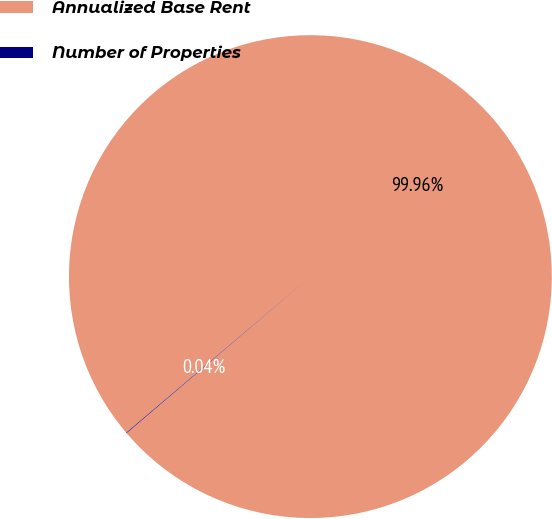Convert chart to OTSL. <chart><loc_0><loc_0><loc_500><loc_500><pie_chart><fcel>Annualized Base Rent<fcel>Number of Properties<nl><fcel>99.96%<fcel>0.04%<nl></chart> 